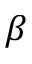Convert formula to latex. <formula><loc_0><loc_0><loc_500><loc_500>\beta</formula> 